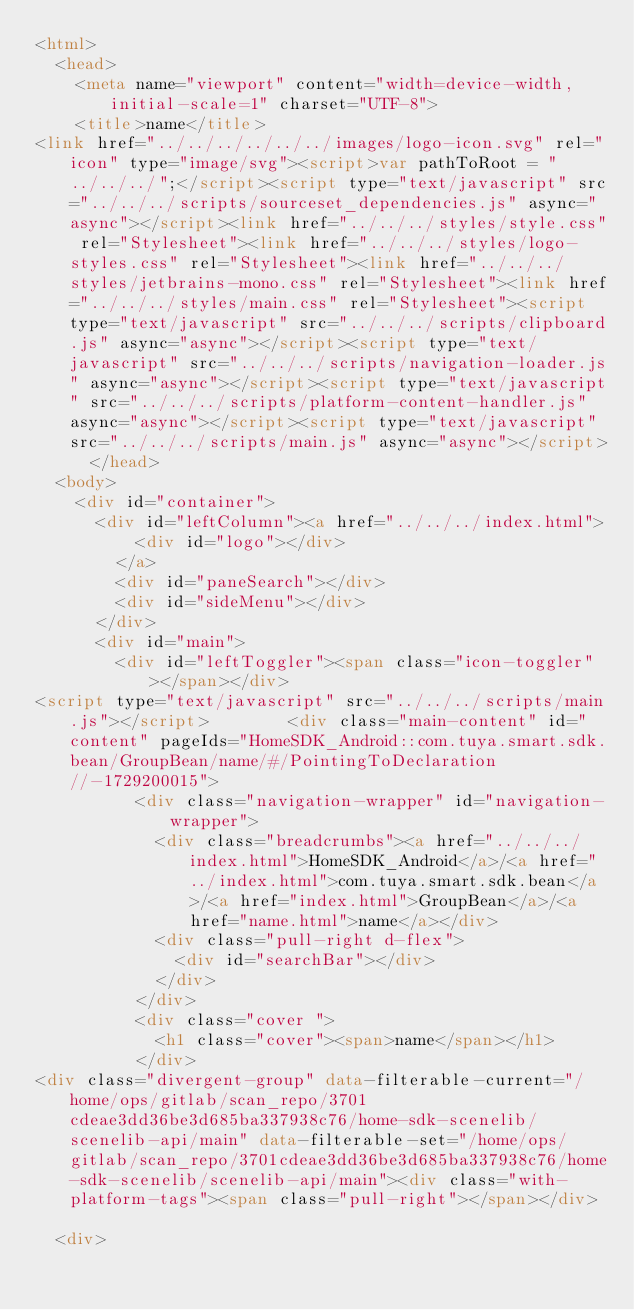Convert code to text. <code><loc_0><loc_0><loc_500><loc_500><_HTML_><html>
  <head>
    <meta name="viewport" content="width=device-width, initial-scale=1" charset="UTF-8">
    <title>name</title>
<link href="../../../../../../images/logo-icon.svg" rel="icon" type="image/svg"><script>var pathToRoot = "../../../";</script><script type="text/javascript" src="../../../scripts/sourceset_dependencies.js" async="async"></script><link href="../../../styles/style.css" rel="Stylesheet"><link href="../../../styles/logo-styles.css" rel="Stylesheet"><link href="../../../styles/jetbrains-mono.css" rel="Stylesheet"><link href="../../../styles/main.css" rel="Stylesheet"><script type="text/javascript" src="../../../scripts/clipboard.js" async="async"></script><script type="text/javascript" src="../../../scripts/navigation-loader.js" async="async"></script><script type="text/javascript" src="../../../scripts/platform-content-handler.js" async="async"></script><script type="text/javascript" src="../../../scripts/main.js" async="async"></script>  </head>
  <body>
    <div id="container">
      <div id="leftColumn"><a href="../../../index.html">
          <div id="logo"></div>
        </a>
        <div id="paneSearch"></div>
        <div id="sideMenu"></div>
      </div>
      <div id="main">
        <div id="leftToggler"><span class="icon-toggler"></span></div>
<script type="text/javascript" src="../../../scripts/main.js"></script>        <div class="main-content" id="content" pageIds="HomeSDK_Android::com.tuya.smart.sdk.bean/GroupBean/name/#/PointingToDeclaration//-1729200015">
          <div class="navigation-wrapper" id="navigation-wrapper">
            <div class="breadcrumbs"><a href="../../../index.html">HomeSDK_Android</a>/<a href="../index.html">com.tuya.smart.sdk.bean</a>/<a href="index.html">GroupBean</a>/<a href="name.html">name</a></div>
            <div class="pull-right d-flex">
              <div id="searchBar"></div>
            </div>
          </div>
          <div class="cover ">
            <h1 class="cover"><span>name</span></h1>
          </div>
<div class="divergent-group" data-filterable-current="/home/ops/gitlab/scan_repo/3701cdeae3dd36be3d685ba337938c76/home-sdk-scenelib/scenelib-api/main" data-filterable-set="/home/ops/gitlab/scan_repo/3701cdeae3dd36be3d685ba337938c76/home-sdk-scenelib/scenelib-api/main"><div class="with-platform-tags"><span class="pull-right"></span></div>

  <div></code> 